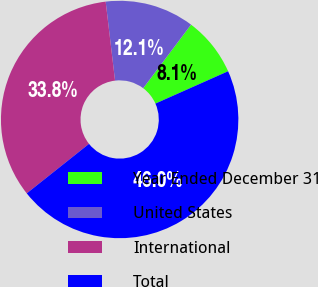Convert chart to OTSL. <chart><loc_0><loc_0><loc_500><loc_500><pie_chart><fcel>Year Ended December 31<fcel>United States<fcel>International<fcel>Total<nl><fcel>8.07%<fcel>12.15%<fcel>33.81%<fcel>45.97%<nl></chart> 